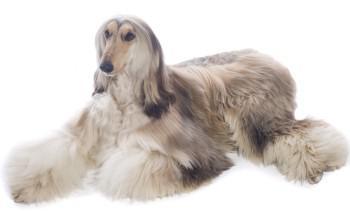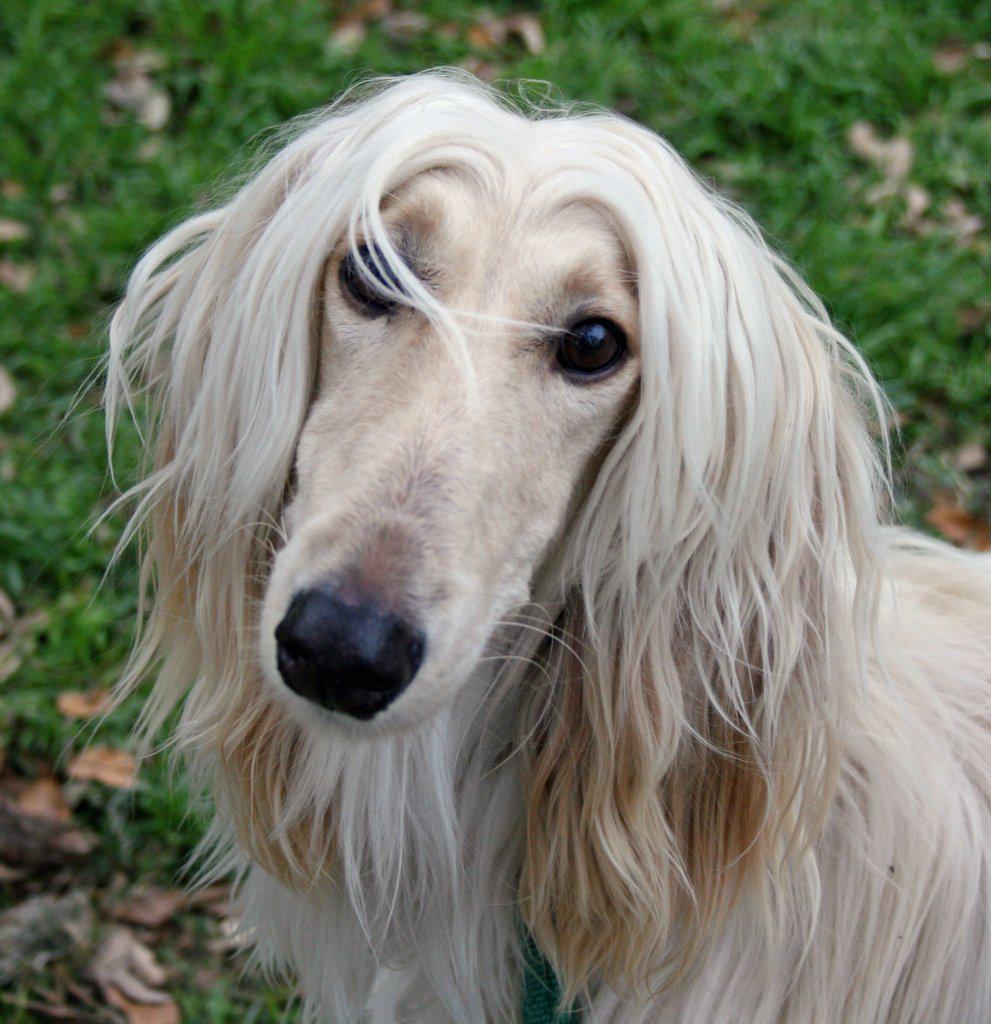The first image is the image on the left, the second image is the image on the right. Considering the images on both sides, is "At least one of the dogs is standing, and you can see a full body shot of the standing dog." valid? Answer yes or no. No. The first image is the image on the left, the second image is the image on the right. Analyze the images presented: Is the assertion "In at least one image, there is a single dog with brown tipped ears and small curled tail, facing left with its feet on grass." valid? Answer yes or no. No. 